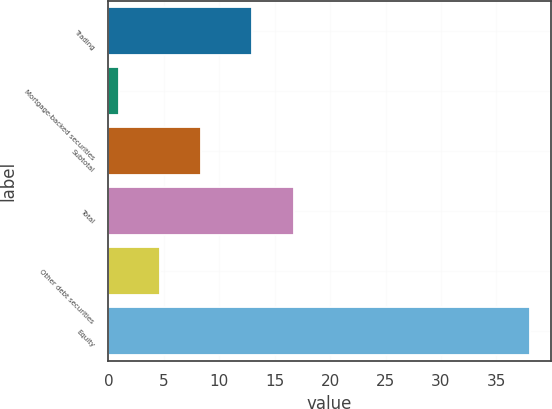Convert chart. <chart><loc_0><loc_0><loc_500><loc_500><bar_chart><fcel>Trading<fcel>Mortgage-backed securities<fcel>Subtotal<fcel>Total<fcel>Other debt securities<fcel>Equity<nl><fcel>13<fcel>1<fcel>8.4<fcel>16.7<fcel>4.7<fcel>38<nl></chart> 